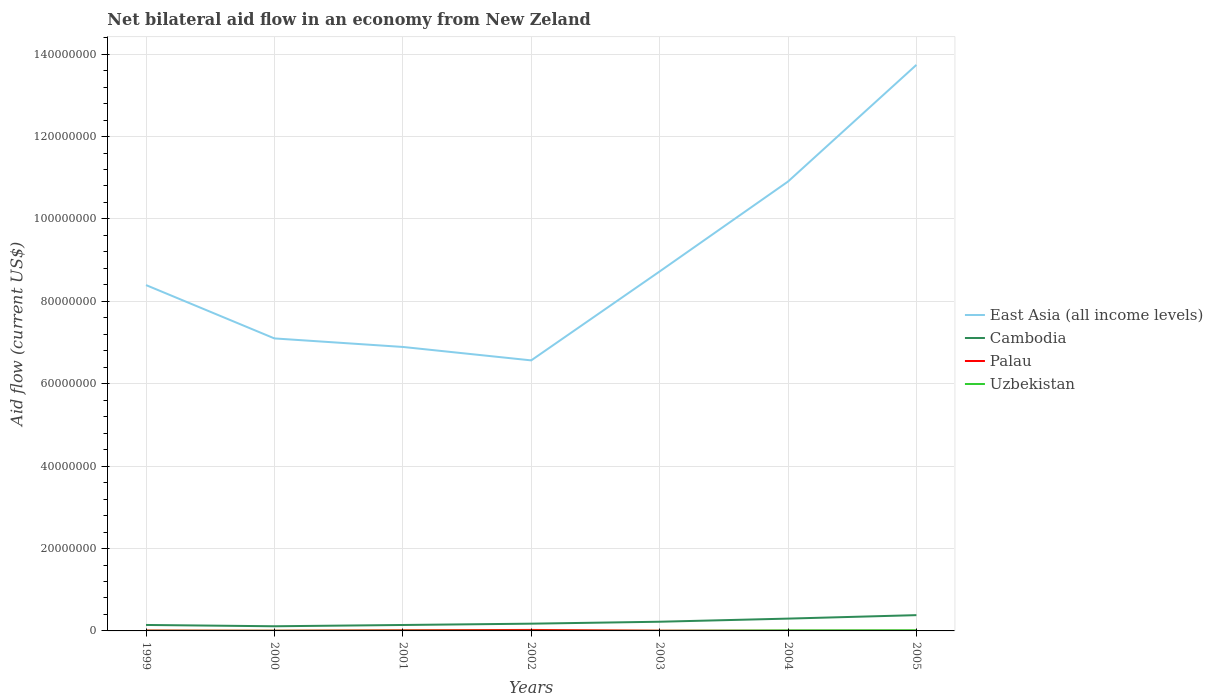Is the number of lines equal to the number of legend labels?
Offer a very short reply. Yes. Across all years, what is the maximum net bilateral aid flow in East Asia (all income levels)?
Your response must be concise. 6.57e+07. In which year was the net bilateral aid flow in Cambodia maximum?
Ensure brevity in your answer.  2000. What is the total net bilateral aid flow in Palau in the graph?
Make the answer very short. 4.00e+04. How many lines are there?
Offer a very short reply. 4. How many years are there in the graph?
Provide a succinct answer. 7. Are the values on the major ticks of Y-axis written in scientific E-notation?
Give a very brief answer. No. Does the graph contain grids?
Ensure brevity in your answer.  Yes. How many legend labels are there?
Provide a succinct answer. 4. What is the title of the graph?
Your response must be concise. Net bilateral aid flow in an economy from New Zeland. Does "Singapore" appear as one of the legend labels in the graph?
Offer a very short reply. No. What is the label or title of the X-axis?
Ensure brevity in your answer.  Years. What is the Aid flow (current US$) of East Asia (all income levels) in 1999?
Give a very brief answer. 8.40e+07. What is the Aid flow (current US$) in Cambodia in 1999?
Ensure brevity in your answer.  1.45e+06. What is the Aid flow (current US$) in Uzbekistan in 1999?
Your response must be concise. 3.00e+04. What is the Aid flow (current US$) in East Asia (all income levels) in 2000?
Make the answer very short. 7.10e+07. What is the Aid flow (current US$) in Cambodia in 2000?
Your answer should be very brief. 1.13e+06. What is the Aid flow (current US$) in Uzbekistan in 2000?
Keep it short and to the point. 3.00e+04. What is the Aid flow (current US$) of East Asia (all income levels) in 2001?
Your response must be concise. 6.89e+07. What is the Aid flow (current US$) in Cambodia in 2001?
Make the answer very short. 1.44e+06. What is the Aid flow (current US$) of Uzbekistan in 2001?
Ensure brevity in your answer.  4.00e+04. What is the Aid flow (current US$) in East Asia (all income levels) in 2002?
Your answer should be compact. 6.57e+07. What is the Aid flow (current US$) of Cambodia in 2002?
Your answer should be very brief. 1.76e+06. What is the Aid flow (current US$) of Palau in 2002?
Offer a terse response. 2.40e+05. What is the Aid flow (current US$) of Uzbekistan in 2002?
Make the answer very short. 2.00e+04. What is the Aid flow (current US$) of East Asia (all income levels) in 2003?
Offer a terse response. 8.72e+07. What is the Aid flow (current US$) of Cambodia in 2003?
Your answer should be compact. 2.23e+06. What is the Aid flow (current US$) in Palau in 2003?
Provide a succinct answer. 6.00e+04. What is the Aid flow (current US$) in East Asia (all income levels) in 2004?
Offer a terse response. 1.09e+08. What is the Aid flow (current US$) in Cambodia in 2004?
Make the answer very short. 2.99e+06. What is the Aid flow (current US$) in Uzbekistan in 2004?
Provide a short and direct response. 1.30e+05. What is the Aid flow (current US$) of East Asia (all income levels) in 2005?
Provide a short and direct response. 1.37e+08. What is the Aid flow (current US$) in Cambodia in 2005?
Provide a short and direct response. 3.83e+06. What is the Aid flow (current US$) in Palau in 2005?
Offer a terse response. 3.00e+04. What is the Aid flow (current US$) in Uzbekistan in 2005?
Ensure brevity in your answer.  1.60e+05. Across all years, what is the maximum Aid flow (current US$) of East Asia (all income levels)?
Give a very brief answer. 1.37e+08. Across all years, what is the maximum Aid flow (current US$) of Cambodia?
Make the answer very short. 3.83e+06. Across all years, what is the maximum Aid flow (current US$) of Palau?
Give a very brief answer. 2.40e+05. Across all years, what is the maximum Aid flow (current US$) of Uzbekistan?
Keep it short and to the point. 1.60e+05. Across all years, what is the minimum Aid flow (current US$) in East Asia (all income levels)?
Ensure brevity in your answer.  6.57e+07. Across all years, what is the minimum Aid flow (current US$) of Cambodia?
Provide a succinct answer. 1.13e+06. What is the total Aid flow (current US$) of East Asia (all income levels) in the graph?
Keep it short and to the point. 6.23e+08. What is the total Aid flow (current US$) of Cambodia in the graph?
Offer a very short reply. 1.48e+07. What is the total Aid flow (current US$) of Palau in the graph?
Provide a short and direct response. 6.70e+05. What is the total Aid flow (current US$) in Uzbekistan in the graph?
Offer a very short reply. 4.30e+05. What is the difference between the Aid flow (current US$) in East Asia (all income levels) in 1999 and that in 2000?
Your response must be concise. 1.30e+07. What is the difference between the Aid flow (current US$) of Cambodia in 1999 and that in 2000?
Provide a succinct answer. 3.20e+05. What is the difference between the Aid flow (current US$) in East Asia (all income levels) in 1999 and that in 2001?
Ensure brevity in your answer.  1.50e+07. What is the difference between the Aid flow (current US$) of Cambodia in 1999 and that in 2001?
Your response must be concise. 10000. What is the difference between the Aid flow (current US$) of Palau in 1999 and that in 2001?
Provide a short and direct response. -6.00e+04. What is the difference between the Aid flow (current US$) of East Asia (all income levels) in 1999 and that in 2002?
Offer a very short reply. 1.83e+07. What is the difference between the Aid flow (current US$) of Cambodia in 1999 and that in 2002?
Ensure brevity in your answer.  -3.10e+05. What is the difference between the Aid flow (current US$) in Uzbekistan in 1999 and that in 2002?
Offer a very short reply. 10000. What is the difference between the Aid flow (current US$) of East Asia (all income levels) in 1999 and that in 2003?
Provide a short and direct response. -3.30e+06. What is the difference between the Aid flow (current US$) in Cambodia in 1999 and that in 2003?
Provide a succinct answer. -7.80e+05. What is the difference between the Aid flow (current US$) in Palau in 1999 and that in 2003?
Offer a very short reply. 4.00e+04. What is the difference between the Aid flow (current US$) in East Asia (all income levels) in 1999 and that in 2004?
Offer a very short reply. -2.51e+07. What is the difference between the Aid flow (current US$) in Cambodia in 1999 and that in 2004?
Make the answer very short. -1.54e+06. What is the difference between the Aid flow (current US$) of East Asia (all income levels) in 1999 and that in 2005?
Provide a succinct answer. -5.34e+07. What is the difference between the Aid flow (current US$) in Cambodia in 1999 and that in 2005?
Ensure brevity in your answer.  -2.38e+06. What is the difference between the Aid flow (current US$) in Uzbekistan in 1999 and that in 2005?
Offer a terse response. -1.30e+05. What is the difference between the Aid flow (current US$) in East Asia (all income levels) in 2000 and that in 2001?
Offer a very short reply. 2.07e+06. What is the difference between the Aid flow (current US$) in Cambodia in 2000 and that in 2001?
Make the answer very short. -3.10e+05. What is the difference between the Aid flow (current US$) in East Asia (all income levels) in 2000 and that in 2002?
Offer a very short reply. 5.33e+06. What is the difference between the Aid flow (current US$) in Cambodia in 2000 and that in 2002?
Ensure brevity in your answer.  -6.30e+05. What is the difference between the Aid flow (current US$) of Palau in 2000 and that in 2002?
Offer a terse response. -1.90e+05. What is the difference between the Aid flow (current US$) of East Asia (all income levels) in 2000 and that in 2003?
Keep it short and to the point. -1.62e+07. What is the difference between the Aid flow (current US$) of Cambodia in 2000 and that in 2003?
Ensure brevity in your answer.  -1.10e+06. What is the difference between the Aid flow (current US$) of East Asia (all income levels) in 2000 and that in 2004?
Ensure brevity in your answer.  -3.81e+07. What is the difference between the Aid flow (current US$) of Cambodia in 2000 and that in 2004?
Your answer should be compact. -1.86e+06. What is the difference between the Aid flow (current US$) of Palau in 2000 and that in 2004?
Offer a terse response. 2.00e+04. What is the difference between the Aid flow (current US$) of East Asia (all income levels) in 2000 and that in 2005?
Make the answer very short. -6.64e+07. What is the difference between the Aid flow (current US$) of Cambodia in 2000 and that in 2005?
Offer a very short reply. -2.70e+06. What is the difference between the Aid flow (current US$) of Uzbekistan in 2000 and that in 2005?
Offer a very short reply. -1.30e+05. What is the difference between the Aid flow (current US$) in East Asia (all income levels) in 2001 and that in 2002?
Ensure brevity in your answer.  3.26e+06. What is the difference between the Aid flow (current US$) of Cambodia in 2001 and that in 2002?
Ensure brevity in your answer.  -3.20e+05. What is the difference between the Aid flow (current US$) of Palau in 2001 and that in 2002?
Make the answer very short. -8.00e+04. What is the difference between the Aid flow (current US$) in Uzbekistan in 2001 and that in 2002?
Provide a short and direct response. 2.00e+04. What is the difference between the Aid flow (current US$) in East Asia (all income levels) in 2001 and that in 2003?
Your response must be concise. -1.83e+07. What is the difference between the Aid flow (current US$) of Cambodia in 2001 and that in 2003?
Your answer should be very brief. -7.90e+05. What is the difference between the Aid flow (current US$) of Palau in 2001 and that in 2003?
Offer a terse response. 1.00e+05. What is the difference between the Aid flow (current US$) in East Asia (all income levels) in 2001 and that in 2004?
Your answer should be very brief. -4.02e+07. What is the difference between the Aid flow (current US$) of Cambodia in 2001 and that in 2004?
Your answer should be very brief. -1.55e+06. What is the difference between the Aid flow (current US$) in Palau in 2001 and that in 2004?
Offer a very short reply. 1.30e+05. What is the difference between the Aid flow (current US$) in Uzbekistan in 2001 and that in 2004?
Provide a succinct answer. -9.00e+04. What is the difference between the Aid flow (current US$) in East Asia (all income levels) in 2001 and that in 2005?
Your answer should be very brief. -6.85e+07. What is the difference between the Aid flow (current US$) of Cambodia in 2001 and that in 2005?
Offer a very short reply. -2.39e+06. What is the difference between the Aid flow (current US$) of Uzbekistan in 2001 and that in 2005?
Make the answer very short. -1.20e+05. What is the difference between the Aid flow (current US$) in East Asia (all income levels) in 2002 and that in 2003?
Give a very brief answer. -2.16e+07. What is the difference between the Aid flow (current US$) of Cambodia in 2002 and that in 2003?
Give a very brief answer. -4.70e+05. What is the difference between the Aid flow (current US$) of Palau in 2002 and that in 2003?
Provide a succinct answer. 1.80e+05. What is the difference between the Aid flow (current US$) of East Asia (all income levels) in 2002 and that in 2004?
Offer a terse response. -4.34e+07. What is the difference between the Aid flow (current US$) of Cambodia in 2002 and that in 2004?
Provide a succinct answer. -1.23e+06. What is the difference between the Aid flow (current US$) in East Asia (all income levels) in 2002 and that in 2005?
Ensure brevity in your answer.  -7.17e+07. What is the difference between the Aid flow (current US$) of Cambodia in 2002 and that in 2005?
Ensure brevity in your answer.  -2.07e+06. What is the difference between the Aid flow (current US$) in Palau in 2002 and that in 2005?
Your answer should be very brief. 2.10e+05. What is the difference between the Aid flow (current US$) in East Asia (all income levels) in 2003 and that in 2004?
Keep it short and to the point. -2.18e+07. What is the difference between the Aid flow (current US$) of Cambodia in 2003 and that in 2004?
Offer a very short reply. -7.60e+05. What is the difference between the Aid flow (current US$) in Uzbekistan in 2003 and that in 2004?
Provide a short and direct response. -1.10e+05. What is the difference between the Aid flow (current US$) of East Asia (all income levels) in 2003 and that in 2005?
Give a very brief answer. -5.02e+07. What is the difference between the Aid flow (current US$) of Cambodia in 2003 and that in 2005?
Your answer should be very brief. -1.60e+06. What is the difference between the Aid flow (current US$) in Palau in 2003 and that in 2005?
Make the answer very short. 3.00e+04. What is the difference between the Aid flow (current US$) of Uzbekistan in 2003 and that in 2005?
Provide a succinct answer. -1.40e+05. What is the difference between the Aid flow (current US$) of East Asia (all income levels) in 2004 and that in 2005?
Make the answer very short. -2.83e+07. What is the difference between the Aid flow (current US$) in Cambodia in 2004 and that in 2005?
Give a very brief answer. -8.40e+05. What is the difference between the Aid flow (current US$) of Palau in 2004 and that in 2005?
Give a very brief answer. 0. What is the difference between the Aid flow (current US$) of Uzbekistan in 2004 and that in 2005?
Give a very brief answer. -3.00e+04. What is the difference between the Aid flow (current US$) in East Asia (all income levels) in 1999 and the Aid flow (current US$) in Cambodia in 2000?
Your response must be concise. 8.28e+07. What is the difference between the Aid flow (current US$) in East Asia (all income levels) in 1999 and the Aid flow (current US$) in Palau in 2000?
Your answer should be compact. 8.39e+07. What is the difference between the Aid flow (current US$) in East Asia (all income levels) in 1999 and the Aid flow (current US$) in Uzbekistan in 2000?
Offer a terse response. 8.39e+07. What is the difference between the Aid flow (current US$) of Cambodia in 1999 and the Aid flow (current US$) of Palau in 2000?
Offer a very short reply. 1.40e+06. What is the difference between the Aid flow (current US$) of Cambodia in 1999 and the Aid flow (current US$) of Uzbekistan in 2000?
Ensure brevity in your answer.  1.42e+06. What is the difference between the Aid flow (current US$) in East Asia (all income levels) in 1999 and the Aid flow (current US$) in Cambodia in 2001?
Provide a succinct answer. 8.25e+07. What is the difference between the Aid flow (current US$) in East Asia (all income levels) in 1999 and the Aid flow (current US$) in Palau in 2001?
Your answer should be very brief. 8.38e+07. What is the difference between the Aid flow (current US$) of East Asia (all income levels) in 1999 and the Aid flow (current US$) of Uzbekistan in 2001?
Give a very brief answer. 8.39e+07. What is the difference between the Aid flow (current US$) in Cambodia in 1999 and the Aid flow (current US$) in Palau in 2001?
Your answer should be compact. 1.29e+06. What is the difference between the Aid flow (current US$) of Cambodia in 1999 and the Aid flow (current US$) of Uzbekistan in 2001?
Ensure brevity in your answer.  1.41e+06. What is the difference between the Aid flow (current US$) of East Asia (all income levels) in 1999 and the Aid flow (current US$) of Cambodia in 2002?
Your answer should be compact. 8.22e+07. What is the difference between the Aid flow (current US$) of East Asia (all income levels) in 1999 and the Aid flow (current US$) of Palau in 2002?
Give a very brief answer. 8.37e+07. What is the difference between the Aid flow (current US$) in East Asia (all income levels) in 1999 and the Aid flow (current US$) in Uzbekistan in 2002?
Make the answer very short. 8.39e+07. What is the difference between the Aid flow (current US$) of Cambodia in 1999 and the Aid flow (current US$) of Palau in 2002?
Provide a succinct answer. 1.21e+06. What is the difference between the Aid flow (current US$) in Cambodia in 1999 and the Aid flow (current US$) in Uzbekistan in 2002?
Offer a very short reply. 1.43e+06. What is the difference between the Aid flow (current US$) of East Asia (all income levels) in 1999 and the Aid flow (current US$) of Cambodia in 2003?
Provide a succinct answer. 8.17e+07. What is the difference between the Aid flow (current US$) in East Asia (all income levels) in 1999 and the Aid flow (current US$) in Palau in 2003?
Your answer should be very brief. 8.39e+07. What is the difference between the Aid flow (current US$) in East Asia (all income levels) in 1999 and the Aid flow (current US$) in Uzbekistan in 2003?
Provide a succinct answer. 8.39e+07. What is the difference between the Aid flow (current US$) of Cambodia in 1999 and the Aid flow (current US$) of Palau in 2003?
Your response must be concise. 1.39e+06. What is the difference between the Aid flow (current US$) of Cambodia in 1999 and the Aid flow (current US$) of Uzbekistan in 2003?
Your response must be concise. 1.43e+06. What is the difference between the Aid flow (current US$) of East Asia (all income levels) in 1999 and the Aid flow (current US$) of Cambodia in 2004?
Offer a very short reply. 8.10e+07. What is the difference between the Aid flow (current US$) of East Asia (all income levels) in 1999 and the Aid flow (current US$) of Palau in 2004?
Your response must be concise. 8.39e+07. What is the difference between the Aid flow (current US$) of East Asia (all income levels) in 1999 and the Aid flow (current US$) of Uzbekistan in 2004?
Your response must be concise. 8.38e+07. What is the difference between the Aid flow (current US$) in Cambodia in 1999 and the Aid flow (current US$) in Palau in 2004?
Provide a short and direct response. 1.42e+06. What is the difference between the Aid flow (current US$) in Cambodia in 1999 and the Aid flow (current US$) in Uzbekistan in 2004?
Your answer should be compact. 1.32e+06. What is the difference between the Aid flow (current US$) of Palau in 1999 and the Aid flow (current US$) of Uzbekistan in 2004?
Give a very brief answer. -3.00e+04. What is the difference between the Aid flow (current US$) in East Asia (all income levels) in 1999 and the Aid flow (current US$) in Cambodia in 2005?
Provide a succinct answer. 8.01e+07. What is the difference between the Aid flow (current US$) of East Asia (all income levels) in 1999 and the Aid flow (current US$) of Palau in 2005?
Keep it short and to the point. 8.39e+07. What is the difference between the Aid flow (current US$) of East Asia (all income levels) in 1999 and the Aid flow (current US$) of Uzbekistan in 2005?
Keep it short and to the point. 8.38e+07. What is the difference between the Aid flow (current US$) of Cambodia in 1999 and the Aid flow (current US$) of Palau in 2005?
Ensure brevity in your answer.  1.42e+06. What is the difference between the Aid flow (current US$) in Cambodia in 1999 and the Aid flow (current US$) in Uzbekistan in 2005?
Your answer should be very brief. 1.29e+06. What is the difference between the Aid flow (current US$) in Palau in 1999 and the Aid flow (current US$) in Uzbekistan in 2005?
Provide a short and direct response. -6.00e+04. What is the difference between the Aid flow (current US$) of East Asia (all income levels) in 2000 and the Aid flow (current US$) of Cambodia in 2001?
Make the answer very short. 6.96e+07. What is the difference between the Aid flow (current US$) of East Asia (all income levels) in 2000 and the Aid flow (current US$) of Palau in 2001?
Make the answer very short. 7.08e+07. What is the difference between the Aid flow (current US$) of East Asia (all income levels) in 2000 and the Aid flow (current US$) of Uzbekistan in 2001?
Offer a very short reply. 7.10e+07. What is the difference between the Aid flow (current US$) in Cambodia in 2000 and the Aid flow (current US$) in Palau in 2001?
Your response must be concise. 9.70e+05. What is the difference between the Aid flow (current US$) in Cambodia in 2000 and the Aid flow (current US$) in Uzbekistan in 2001?
Give a very brief answer. 1.09e+06. What is the difference between the Aid flow (current US$) in East Asia (all income levels) in 2000 and the Aid flow (current US$) in Cambodia in 2002?
Make the answer very short. 6.92e+07. What is the difference between the Aid flow (current US$) of East Asia (all income levels) in 2000 and the Aid flow (current US$) of Palau in 2002?
Offer a very short reply. 7.08e+07. What is the difference between the Aid flow (current US$) in East Asia (all income levels) in 2000 and the Aid flow (current US$) in Uzbekistan in 2002?
Offer a very short reply. 7.10e+07. What is the difference between the Aid flow (current US$) of Cambodia in 2000 and the Aid flow (current US$) of Palau in 2002?
Provide a succinct answer. 8.90e+05. What is the difference between the Aid flow (current US$) of Cambodia in 2000 and the Aid flow (current US$) of Uzbekistan in 2002?
Your response must be concise. 1.11e+06. What is the difference between the Aid flow (current US$) of Palau in 2000 and the Aid flow (current US$) of Uzbekistan in 2002?
Ensure brevity in your answer.  3.00e+04. What is the difference between the Aid flow (current US$) in East Asia (all income levels) in 2000 and the Aid flow (current US$) in Cambodia in 2003?
Make the answer very short. 6.88e+07. What is the difference between the Aid flow (current US$) in East Asia (all income levels) in 2000 and the Aid flow (current US$) in Palau in 2003?
Offer a terse response. 7.09e+07. What is the difference between the Aid flow (current US$) of East Asia (all income levels) in 2000 and the Aid flow (current US$) of Uzbekistan in 2003?
Provide a succinct answer. 7.10e+07. What is the difference between the Aid flow (current US$) in Cambodia in 2000 and the Aid flow (current US$) in Palau in 2003?
Ensure brevity in your answer.  1.07e+06. What is the difference between the Aid flow (current US$) in Cambodia in 2000 and the Aid flow (current US$) in Uzbekistan in 2003?
Keep it short and to the point. 1.11e+06. What is the difference between the Aid flow (current US$) in Palau in 2000 and the Aid flow (current US$) in Uzbekistan in 2003?
Your response must be concise. 3.00e+04. What is the difference between the Aid flow (current US$) of East Asia (all income levels) in 2000 and the Aid flow (current US$) of Cambodia in 2004?
Provide a succinct answer. 6.80e+07. What is the difference between the Aid flow (current US$) in East Asia (all income levels) in 2000 and the Aid flow (current US$) in Palau in 2004?
Make the answer very short. 7.10e+07. What is the difference between the Aid flow (current US$) in East Asia (all income levels) in 2000 and the Aid flow (current US$) in Uzbekistan in 2004?
Make the answer very short. 7.09e+07. What is the difference between the Aid flow (current US$) of Cambodia in 2000 and the Aid flow (current US$) of Palau in 2004?
Keep it short and to the point. 1.10e+06. What is the difference between the Aid flow (current US$) of Palau in 2000 and the Aid flow (current US$) of Uzbekistan in 2004?
Keep it short and to the point. -8.00e+04. What is the difference between the Aid flow (current US$) in East Asia (all income levels) in 2000 and the Aid flow (current US$) in Cambodia in 2005?
Your response must be concise. 6.72e+07. What is the difference between the Aid flow (current US$) of East Asia (all income levels) in 2000 and the Aid flow (current US$) of Palau in 2005?
Your answer should be very brief. 7.10e+07. What is the difference between the Aid flow (current US$) in East Asia (all income levels) in 2000 and the Aid flow (current US$) in Uzbekistan in 2005?
Your response must be concise. 7.08e+07. What is the difference between the Aid flow (current US$) in Cambodia in 2000 and the Aid flow (current US$) in Palau in 2005?
Your answer should be very brief. 1.10e+06. What is the difference between the Aid flow (current US$) in Cambodia in 2000 and the Aid flow (current US$) in Uzbekistan in 2005?
Offer a very short reply. 9.70e+05. What is the difference between the Aid flow (current US$) in East Asia (all income levels) in 2001 and the Aid flow (current US$) in Cambodia in 2002?
Offer a terse response. 6.72e+07. What is the difference between the Aid flow (current US$) in East Asia (all income levels) in 2001 and the Aid flow (current US$) in Palau in 2002?
Ensure brevity in your answer.  6.87e+07. What is the difference between the Aid flow (current US$) in East Asia (all income levels) in 2001 and the Aid flow (current US$) in Uzbekistan in 2002?
Ensure brevity in your answer.  6.89e+07. What is the difference between the Aid flow (current US$) in Cambodia in 2001 and the Aid flow (current US$) in Palau in 2002?
Offer a terse response. 1.20e+06. What is the difference between the Aid flow (current US$) in Cambodia in 2001 and the Aid flow (current US$) in Uzbekistan in 2002?
Ensure brevity in your answer.  1.42e+06. What is the difference between the Aid flow (current US$) of Palau in 2001 and the Aid flow (current US$) of Uzbekistan in 2002?
Your answer should be compact. 1.40e+05. What is the difference between the Aid flow (current US$) in East Asia (all income levels) in 2001 and the Aid flow (current US$) in Cambodia in 2003?
Your answer should be compact. 6.67e+07. What is the difference between the Aid flow (current US$) in East Asia (all income levels) in 2001 and the Aid flow (current US$) in Palau in 2003?
Offer a terse response. 6.89e+07. What is the difference between the Aid flow (current US$) in East Asia (all income levels) in 2001 and the Aid flow (current US$) in Uzbekistan in 2003?
Provide a succinct answer. 6.89e+07. What is the difference between the Aid flow (current US$) in Cambodia in 2001 and the Aid flow (current US$) in Palau in 2003?
Offer a terse response. 1.38e+06. What is the difference between the Aid flow (current US$) in Cambodia in 2001 and the Aid flow (current US$) in Uzbekistan in 2003?
Provide a succinct answer. 1.42e+06. What is the difference between the Aid flow (current US$) in Palau in 2001 and the Aid flow (current US$) in Uzbekistan in 2003?
Give a very brief answer. 1.40e+05. What is the difference between the Aid flow (current US$) of East Asia (all income levels) in 2001 and the Aid flow (current US$) of Cambodia in 2004?
Provide a short and direct response. 6.59e+07. What is the difference between the Aid flow (current US$) of East Asia (all income levels) in 2001 and the Aid flow (current US$) of Palau in 2004?
Keep it short and to the point. 6.89e+07. What is the difference between the Aid flow (current US$) of East Asia (all income levels) in 2001 and the Aid flow (current US$) of Uzbekistan in 2004?
Your answer should be very brief. 6.88e+07. What is the difference between the Aid flow (current US$) of Cambodia in 2001 and the Aid flow (current US$) of Palau in 2004?
Provide a short and direct response. 1.41e+06. What is the difference between the Aid flow (current US$) in Cambodia in 2001 and the Aid flow (current US$) in Uzbekistan in 2004?
Ensure brevity in your answer.  1.31e+06. What is the difference between the Aid flow (current US$) in East Asia (all income levels) in 2001 and the Aid flow (current US$) in Cambodia in 2005?
Provide a succinct answer. 6.51e+07. What is the difference between the Aid flow (current US$) of East Asia (all income levels) in 2001 and the Aid flow (current US$) of Palau in 2005?
Offer a terse response. 6.89e+07. What is the difference between the Aid flow (current US$) of East Asia (all income levels) in 2001 and the Aid flow (current US$) of Uzbekistan in 2005?
Your answer should be very brief. 6.88e+07. What is the difference between the Aid flow (current US$) in Cambodia in 2001 and the Aid flow (current US$) in Palau in 2005?
Offer a terse response. 1.41e+06. What is the difference between the Aid flow (current US$) in Cambodia in 2001 and the Aid flow (current US$) in Uzbekistan in 2005?
Offer a terse response. 1.28e+06. What is the difference between the Aid flow (current US$) in Palau in 2001 and the Aid flow (current US$) in Uzbekistan in 2005?
Offer a terse response. 0. What is the difference between the Aid flow (current US$) of East Asia (all income levels) in 2002 and the Aid flow (current US$) of Cambodia in 2003?
Offer a terse response. 6.34e+07. What is the difference between the Aid flow (current US$) in East Asia (all income levels) in 2002 and the Aid flow (current US$) in Palau in 2003?
Give a very brief answer. 6.56e+07. What is the difference between the Aid flow (current US$) in East Asia (all income levels) in 2002 and the Aid flow (current US$) in Uzbekistan in 2003?
Your response must be concise. 6.56e+07. What is the difference between the Aid flow (current US$) of Cambodia in 2002 and the Aid flow (current US$) of Palau in 2003?
Offer a very short reply. 1.70e+06. What is the difference between the Aid flow (current US$) in Cambodia in 2002 and the Aid flow (current US$) in Uzbekistan in 2003?
Your answer should be compact. 1.74e+06. What is the difference between the Aid flow (current US$) of Palau in 2002 and the Aid flow (current US$) of Uzbekistan in 2003?
Provide a succinct answer. 2.20e+05. What is the difference between the Aid flow (current US$) of East Asia (all income levels) in 2002 and the Aid flow (current US$) of Cambodia in 2004?
Keep it short and to the point. 6.27e+07. What is the difference between the Aid flow (current US$) of East Asia (all income levels) in 2002 and the Aid flow (current US$) of Palau in 2004?
Offer a terse response. 6.56e+07. What is the difference between the Aid flow (current US$) of East Asia (all income levels) in 2002 and the Aid flow (current US$) of Uzbekistan in 2004?
Ensure brevity in your answer.  6.55e+07. What is the difference between the Aid flow (current US$) in Cambodia in 2002 and the Aid flow (current US$) in Palau in 2004?
Keep it short and to the point. 1.73e+06. What is the difference between the Aid flow (current US$) in Cambodia in 2002 and the Aid flow (current US$) in Uzbekistan in 2004?
Give a very brief answer. 1.63e+06. What is the difference between the Aid flow (current US$) of East Asia (all income levels) in 2002 and the Aid flow (current US$) of Cambodia in 2005?
Provide a short and direct response. 6.18e+07. What is the difference between the Aid flow (current US$) in East Asia (all income levels) in 2002 and the Aid flow (current US$) in Palau in 2005?
Make the answer very short. 6.56e+07. What is the difference between the Aid flow (current US$) of East Asia (all income levels) in 2002 and the Aid flow (current US$) of Uzbekistan in 2005?
Your response must be concise. 6.55e+07. What is the difference between the Aid flow (current US$) of Cambodia in 2002 and the Aid flow (current US$) of Palau in 2005?
Provide a succinct answer. 1.73e+06. What is the difference between the Aid flow (current US$) in Cambodia in 2002 and the Aid flow (current US$) in Uzbekistan in 2005?
Give a very brief answer. 1.60e+06. What is the difference between the Aid flow (current US$) of East Asia (all income levels) in 2003 and the Aid flow (current US$) of Cambodia in 2004?
Give a very brief answer. 8.43e+07. What is the difference between the Aid flow (current US$) in East Asia (all income levels) in 2003 and the Aid flow (current US$) in Palau in 2004?
Make the answer very short. 8.72e+07. What is the difference between the Aid flow (current US$) of East Asia (all income levels) in 2003 and the Aid flow (current US$) of Uzbekistan in 2004?
Offer a terse response. 8.71e+07. What is the difference between the Aid flow (current US$) in Cambodia in 2003 and the Aid flow (current US$) in Palau in 2004?
Offer a very short reply. 2.20e+06. What is the difference between the Aid flow (current US$) in Cambodia in 2003 and the Aid flow (current US$) in Uzbekistan in 2004?
Your response must be concise. 2.10e+06. What is the difference between the Aid flow (current US$) in Palau in 2003 and the Aid flow (current US$) in Uzbekistan in 2004?
Your answer should be very brief. -7.00e+04. What is the difference between the Aid flow (current US$) in East Asia (all income levels) in 2003 and the Aid flow (current US$) in Cambodia in 2005?
Provide a short and direct response. 8.34e+07. What is the difference between the Aid flow (current US$) of East Asia (all income levels) in 2003 and the Aid flow (current US$) of Palau in 2005?
Offer a very short reply. 8.72e+07. What is the difference between the Aid flow (current US$) in East Asia (all income levels) in 2003 and the Aid flow (current US$) in Uzbekistan in 2005?
Keep it short and to the point. 8.71e+07. What is the difference between the Aid flow (current US$) in Cambodia in 2003 and the Aid flow (current US$) in Palau in 2005?
Your answer should be very brief. 2.20e+06. What is the difference between the Aid flow (current US$) of Cambodia in 2003 and the Aid flow (current US$) of Uzbekistan in 2005?
Offer a very short reply. 2.07e+06. What is the difference between the Aid flow (current US$) in East Asia (all income levels) in 2004 and the Aid flow (current US$) in Cambodia in 2005?
Provide a short and direct response. 1.05e+08. What is the difference between the Aid flow (current US$) in East Asia (all income levels) in 2004 and the Aid flow (current US$) in Palau in 2005?
Offer a very short reply. 1.09e+08. What is the difference between the Aid flow (current US$) in East Asia (all income levels) in 2004 and the Aid flow (current US$) in Uzbekistan in 2005?
Provide a succinct answer. 1.09e+08. What is the difference between the Aid flow (current US$) of Cambodia in 2004 and the Aid flow (current US$) of Palau in 2005?
Provide a short and direct response. 2.96e+06. What is the difference between the Aid flow (current US$) of Cambodia in 2004 and the Aid flow (current US$) of Uzbekistan in 2005?
Offer a very short reply. 2.83e+06. What is the average Aid flow (current US$) in East Asia (all income levels) per year?
Offer a terse response. 8.90e+07. What is the average Aid flow (current US$) in Cambodia per year?
Keep it short and to the point. 2.12e+06. What is the average Aid flow (current US$) of Palau per year?
Offer a very short reply. 9.57e+04. What is the average Aid flow (current US$) of Uzbekistan per year?
Your answer should be compact. 6.14e+04. In the year 1999, what is the difference between the Aid flow (current US$) of East Asia (all income levels) and Aid flow (current US$) of Cambodia?
Give a very brief answer. 8.25e+07. In the year 1999, what is the difference between the Aid flow (current US$) of East Asia (all income levels) and Aid flow (current US$) of Palau?
Keep it short and to the point. 8.38e+07. In the year 1999, what is the difference between the Aid flow (current US$) in East Asia (all income levels) and Aid flow (current US$) in Uzbekistan?
Keep it short and to the point. 8.39e+07. In the year 1999, what is the difference between the Aid flow (current US$) in Cambodia and Aid flow (current US$) in Palau?
Provide a short and direct response. 1.35e+06. In the year 1999, what is the difference between the Aid flow (current US$) of Cambodia and Aid flow (current US$) of Uzbekistan?
Ensure brevity in your answer.  1.42e+06. In the year 2000, what is the difference between the Aid flow (current US$) in East Asia (all income levels) and Aid flow (current US$) in Cambodia?
Give a very brief answer. 6.99e+07. In the year 2000, what is the difference between the Aid flow (current US$) of East Asia (all income levels) and Aid flow (current US$) of Palau?
Give a very brief answer. 7.10e+07. In the year 2000, what is the difference between the Aid flow (current US$) of East Asia (all income levels) and Aid flow (current US$) of Uzbekistan?
Ensure brevity in your answer.  7.10e+07. In the year 2000, what is the difference between the Aid flow (current US$) in Cambodia and Aid flow (current US$) in Palau?
Make the answer very short. 1.08e+06. In the year 2000, what is the difference between the Aid flow (current US$) in Cambodia and Aid flow (current US$) in Uzbekistan?
Offer a very short reply. 1.10e+06. In the year 2000, what is the difference between the Aid flow (current US$) of Palau and Aid flow (current US$) of Uzbekistan?
Provide a short and direct response. 2.00e+04. In the year 2001, what is the difference between the Aid flow (current US$) of East Asia (all income levels) and Aid flow (current US$) of Cambodia?
Offer a very short reply. 6.75e+07. In the year 2001, what is the difference between the Aid flow (current US$) in East Asia (all income levels) and Aid flow (current US$) in Palau?
Your answer should be very brief. 6.88e+07. In the year 2001, what is the difference between the Aid flow (current US$) of East Asia (all income levels) and Aid flow (current US$) of Uzbekistan?
Your answer should be very brief. 6.89e+07. In the year 2001, what is the difference between the Aid flow (current US$) of Cambodia and Aid flow (current US$) of Palau?
Give a very brief answer. 1.28e+06. In the year 2001, what is the difference between the Aid flow (current US$) of Cambodia and Aid flow (current US$) of Uzbekistan?
Your response must be concise. 1.40e+06. In the year 2001, what is the difference between the Aid flow (current US$) of Palau and Aid flow (current US$) of Uzbekistan?
Give a very brief answer. 1.20e+05. In the year 2002, what is the difference between the Aid flow (current US$) in East Asia (all income levels) and Aid flow (current US$) in Cambodia?
Keep it short and to the point. 6.39e+07. In the year 2002, what is the difference between the Aid flow (current US$) in East Asia (all income levels) and Aid flow (current US$) in Palau?
Your response must be concise. 6.54e+07. In the year 2002, what is the difference between the Aid flow (current US$) in East Asia (all income levels) and Aid flow (current US$) in Uzbekistan?
Provide a short and direct response. 6.56e+07. In the year 2002, what is the difference between the Aid flow (current US$) of Cambodia and Aid flow (current US$) of Palau?
Offer a terse response. 1.52e+06. In the year 2002, what is the difference between the Aid flow (current US$) of Cambodia and Aid flow (current US$) of Uzbekistan?
Give a very brief answer. 1.74e+06. In the year 2003, what is the difference between the Aid flow (current US$) of East Asia (all income levels) and Aid flow (current US$) of Cambodia?
Your response must be concise. 8.50e+07. In the year 2003, what is the difference between the Aid flow (current US$) in East Asia (all income levels) and Aid flow (current US$) in Palau?
Keep it short and to the point. 8.72e+07. In the year 2003, what is the difference between the Aid flow (current US$) of East Asia (all income levels) and Aid flow (current US$) of Uzbekistan?
Your answer should be compact. 8.72e+07. In the year 2003, what is the difference between the Aid flow (current US$) of Cambodia and Aid flow (current US$) of Palau?
Keep it short and to the point. 2.17e+06. In the year 2003, what is the difference between the Aid flow (current US$) in Cambodia and Aid flow (current US$) in Uzbekistan?
Keep it short and to the point. 2.21e+06. In the year 2004, what is the difference between the Aid flow (current US$) in East Asia (all income levels) and Aid flow (current US$) in Cambodia?
Your response must be concise. 1.06e+08. In the year 2004, what is the difference between the Aid flow (current US$) in East Asia (all income levels) and Aid flow (current US$) in Palau?
Offer a terse response. 1.09e+08. In the year 2004, what is the difference between the Aid flow (current US$) in East Asia (all income levels) and Aid flow (current US$) in Uzbekistan?
Provide a short and direct response. 1.09e+08. In the year 2004, what is the difference between the Aid flow (current US$) in Cambodia and Aid flow (current US$) in Palau?
Keep it short and to the point. 2.96e+06. In the year 2004, what is the difference between the Aid flow (current US$) in Cambodia and Aid flow (current US$) in Uzbekistan?
Keep it short and to the point. 2.86e+06. In the year 2004, what is the difference between the Aid flow (current US$) in Palau and Aid flow (current US$) in Uzbekistan?
Provide a short and direct response. -1.00e+05. In the year 2005, what is the difference between the Aid flow (current US$) in East Asia (all income levels) and Aid flow (current US$) in Cambodia?
Your response must be concise. 1.34e+08. In the year 2005, what is the difference between the Aid flow (current US$) in East Asia (all income levels) and Aid flow (current US$) in Palau?
Keep it short and to the point. 1.37e+08. In the year 2005, what is the difference between the Aid flow (current US$) in East Asia (all income levels) and Aid flow (current US$) in Uzbekistan?
Keep it short and to the point. 1.37e+08. In the year 2005, what is the difference between the Aid flow (current US$) of Cambodia and Aid flow (current US$) of Palau?
Offer a terse response. 3.80e+06. In the year 2005, what is the difference between the Aid flow (current US$) of Cambodia and Aid flow (current US$) of Uzbekistan?
Offer a very short reply. 3.67e+06. In the year 2005, what is the difference between the Aid flow (current US$) of Palau and Aid flow (current US$) of Uzbekistan?
Provide a succinct answer. -1.30e+05. What is the ratio of the Aid flow (current US$) in East Asia (all income levels) in 1999 to that in 2000?
Offer a terse response. 1.18. What is the ratio of the Aid flow (current US$) of Cambodia in 1999 to that in 2000?
Keep it short and to the point. 1.28. What is the ratio of the Aid flow (current US$) in East Asia (all income levels) in 1999 to that in 2001?
Keep it short and to the point. 1.22. What is the ratio of the Aid flow (current US$) of Palau in 1999 to that in 2001?
Offer a terse response. 0.62. What is the ratio of the Aid flow (current US$) in East Asia (all income levels) in 1999 to that in 2002?
Provide a short and direct response. 1.28. What is the ratio of the Aid flow (current US$) in Cambodia in 1999 to that in 2002?
Provide a succinct answer. 0.82. What is the ratio of the Aid flow (current US$) of Palau in 1999 to that in 2002?
Offer a very short reply. 0.42. What is the ratio of the Aid flow (current US$) of Uzbekistan in 1999 to that in 2002?
Offer a very short reply. 1.5. What is the ratio of the Aid flow (current US$) of East Asia (all income levels) in 1999 to that in 2003?
Provide a short and direct response. 0.96. What is the ratio of the Aid flow (current US$) in Cambodia in 1999 to that in 2003?
Your response must be concise. 0.65. What is the ratio of the Aid flow (current US$) in Uzbekistan in 1999 to that in 2003?
Your answer should be very brief. 1.5. What is the ratio of the Aid flow (current US$) in East Asia (all income levels) in 1999 to that in 2004?
Provide a short and direct response. 0.77. What is the ratio of the Aid flow (current US$) of Cambodia in 1999 to that in 2004?
Ensure brevity in your answer.  0.48. What is the ratio of the Aid flow (current US$) of Uzbekistan in 1999 to that in 2004?
Offer a terse response. 0.23. What is the ratio of the Aid flow (current US$) in East Asia (all income levels) in 1999 to that in 2005?
Ensure brevity in your answer.  0.61. What is the ratio of the Aid flow (current US$) of Cambodia in 1999 to that in 2005?
Keep it short and to the point. 0.38. What is the ratio of the Aid flow (current US$) in Palau in 1999 to that in 2005?
Offer a very short reply. 3.33. What is the ratio of the Aid flow (current US$) in Uzbekistan in 1999 to that in 2005?
Offer a very short reply. 0.19. What is the ratio of the Aid flow (current US$) in Cambodia in 2000 to that in 2001?
Your response must be concise. 0.78. What is the ratio of the Aid flow (current US$) of Palau in 2000 to that in 2001?
Provide a short and direct response. 0.31. What is the ratio of the Aid flow (current US$) of Uzbekistan in 2000 to that in 2001?
Offer a terse response. 0.75. What is the ratio of the Aid flow (current US$) of East Asia (all income levels) in 2000 to that in 2002?
Give a very brief answer. 1.08. What is the ratio of the Aid flow (current US$) of Cambodia in 2000 to that in 2002?
Offer a terse response. 0.64. What is the ratio of the Aid flow (current US$) in Palau in 2000 to that in 2002?
Offer a very short reply. 0.21. What is the ratio of the Aid flow (current US$) in Uzbekistan in 2000 to that in 2002?
Your answer should be very brief. 1.5. What is the ratio of the Aid flow (current US$) in East Asia (all income levels) in 2000 to that in 2003?
Keep it short and to the point. 0.81. What is the ratio of the Aid flow (current US$) of Cambodia in 2000 to that in 2003?
Make the answer very short. 0.51. What is the ratio of the Aid flow (current US$) in Uzbekistan in 2000 to that in 2003?
Offer a very short reply. 1.5. What is the ratio of the Aid flow (current US$) in East Asia (all income levels) in 2000 to that in 2004?
Offer a very short reply. 0.65. What is the ratio of the Aid flow (current US$) in Cambodia in 2000 to that in 2004?
Your answer should be compact. 0.38. What is the ratio of the Aid flow (current US$) in Palau in 2000 to that in 2004?
Make the answer very short. 1.67. What is the ratio of the Aid flow (current US$) in Uzbekistan in 2000 to that in 2004?
Your answer should be compact. 0.23. What is the ratio of the Aid flow (current US$) of East Asia (all income levels) in 2000 to that in 2005?
Your response must be concise. 0.52. What is the ratio of the Aid flow (current US$) of Cambodia in 2000 to that in 2005?
Offer a very short reply. 0.29. What is the ratio of the Aid flow (current US$) of Uzbekistan in 2000 to that in 2005?
Offer a very short reply. 0.19. What is the ratio of the Aid flow (current US$) in East Asia (all income levels) in 2001 to that in 2002?
Keep it short and to the point. 1.05. What is the ratio of the Aid flow (current US$) of Cambodia in 2001 to that in 2002?
Provide a succinct answer. 0.82. What is the ratio of the Aid flow (current US$) in Palau in 2001 to that in 2002?
Provide a succinct answer. 0.67. What is the ratio of the Aid flow (current US$) in Uzbekistan in 2001 to that in 2002?
Offer a very short reply. 2. What is the ratio of the Aid flow (current US$) of East Asia (all income levels) in 2001 to that in 2003?
Make the answer very short. 0.79. What is the ratio of the Aid flow (current US$) in Cambodia in 2001 to that in 2003?
Ensure brevity in your answer.  0.65. What is the ratio of the Aid flow (current US$) of Palau in 2001 to that in 2003?
Ensure brevity in your answer.  2.67. What is the ratio of the Aid flow (current US$) of East Asia (all income levels) in 2001 to that in 2004?
Provide a short and direct response. 0.63. What is the ratio of the Aid flow (current US$) of Cambodia in 2001 to that in 2004?
Provide a succinct answer. 0.48. What is the ratio of the Aid flow (current US$) of Palau in 2001 to that in 2004?
Make the answer very short. 5.33. What is the ratio of the Aid flow (current US$) in Uzbekistan in 2001 to that in 2004?
Ensure brevity in your answer.  0.31. What is the ratio of the Aid flow (current US$) of East Asia (all income levels) in 2001 to that in 2005?
Provide a short and direct response. 0.5. What is the ratio of the Aid flow (current US$) in Cambodia in 2001 to that in 2005?
Your answer should be compact. 0.38. What is the ratio of the Aid flow (current US$) in Palau in 2001 to that in 2005?
Make the answer very short. 5.33. What is the ratio of the Aid flow (current US$) of Uzbekistan in 2001 to that in 2005?
Your answer should be very brief. 0.25. What is the ratio of the Aid flow (current US$) in East Asia (all income levels) in 2002 to that in 2003?
Your answer should be compact. 0.75. What is the ratio of the Aid flow (current US$) in Cambodia in 2002 to that in 2003?
Ensure brevity in your answer.  0.79. What is the ratio of the Aid flow (current US$) in East Asia (all income levels) in 2002 to that in 2004?
Keep it short and to the point. 0.6. What is the ratio of the Aid flow (current US$) of Cambodia in 2002 to that in 2004?
Provide a succinct answer. 0.59. What is the ratio of the Aid flow (current US$) of Uzbekistan in 2002 to that in 2004?
Give a very brief answer. 0.15. What is the ratio of the Aid flow (current US$) of East Asia (all income levels) in 2002 to that in 2005?
Provide a short and direct response. 0.48. What is the ratio of the Aid flow (current US$) of Cambodia in 2002 to that in 2005?
Offer a terse response. 0.46. What is the ratio of the Aid flow (current US$) of Uzbekistan in 2002 to that in 2005?
Keep it short and to the point. 0.12. What is the ratio of the Aid flow (current US$) of East Asia (all income levels) in 2003 to that in 2004?
Offer a very short reply. 0.8. What is the ratio of the Aid flow (current US$) in Cambodia in 2003 to that in 2004?
Provide a succinct answer. 0.75. What is the ratio of the Aid flow (current US$) in Uzbekistan in 2003 to that in 2004?
Ensure brevity in your answer.  0.15. What is the ratio of the Aid flow (current US$) in East Asia (all income levels) in 2003 to that in 2005?
Offer a very short reply. 0.64. What is the ratio of the Aid flow (current US$) of Cambodia in 2003 to that in 2005?
Your response must be concise. 0.58. What is the ratio of the Aid flow (current US$) of East Asia (all income levels) in 2004 to that in 2005?
Your answer should be compact. 0.79. What is the ratio of the Aid flow (current US$) in Cambodia in 2004 to that in 2005?
Ensure brevity in your answer.  0.78. What is the ratio of the Aid flow (current US$) in Uzbekistan in 2004 to that in 2005?
Make the answer very short. 0.81. What is the difference between the highest and the second highest Aid flow (current US$) of East Asia (all income levels)?
Your response must be concise. 2.83e+07. What is the difference between the highest and the second highest Aid flow (current US$) in Cambodia?
Your answer should be very brief. 8.40e+05. What is the difference between the highest and the second highest Aid flow (current US$) of Uzbekistan?
Your answer should be very brief. 3.00e+04. What is the difference between the highest and the lowest Aid flow (current US$) in East Asia (all income levels)?
Offer a very short reply. 7.17e+07. What is the difference between the highest and the lowest Aid flow (current US$) in Cambodia?
Provide a succinct answer. 2.70e+06. What is the difference between the highest and the lowest Aid flow (current US$) of Uzbekistan?
Keep it short and to the point. 1.40e+05. 